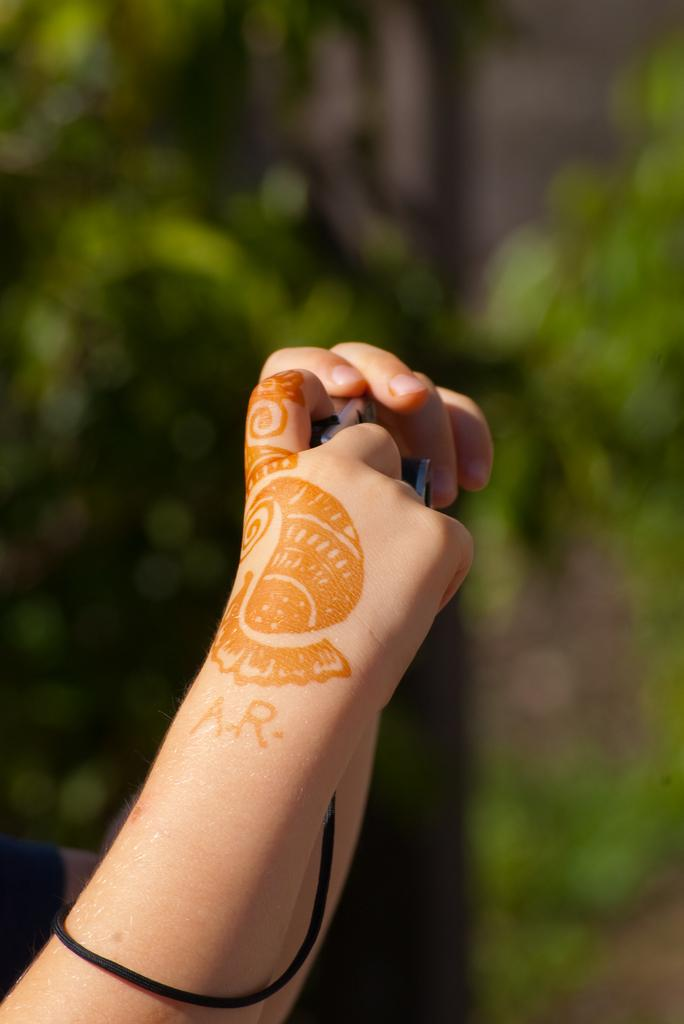What is the main subject in the front of the image? There are human hands in the front of the image. What can be seen in the background of the image? There are trees in the background of the image. How would you describe the background of the image? The background of the image is blurred. What type of arch can be seen in the image? There is no arch present in the image. Is there a church visible in the background of the image? There is no church visible in the image; only trees are present in the background. 